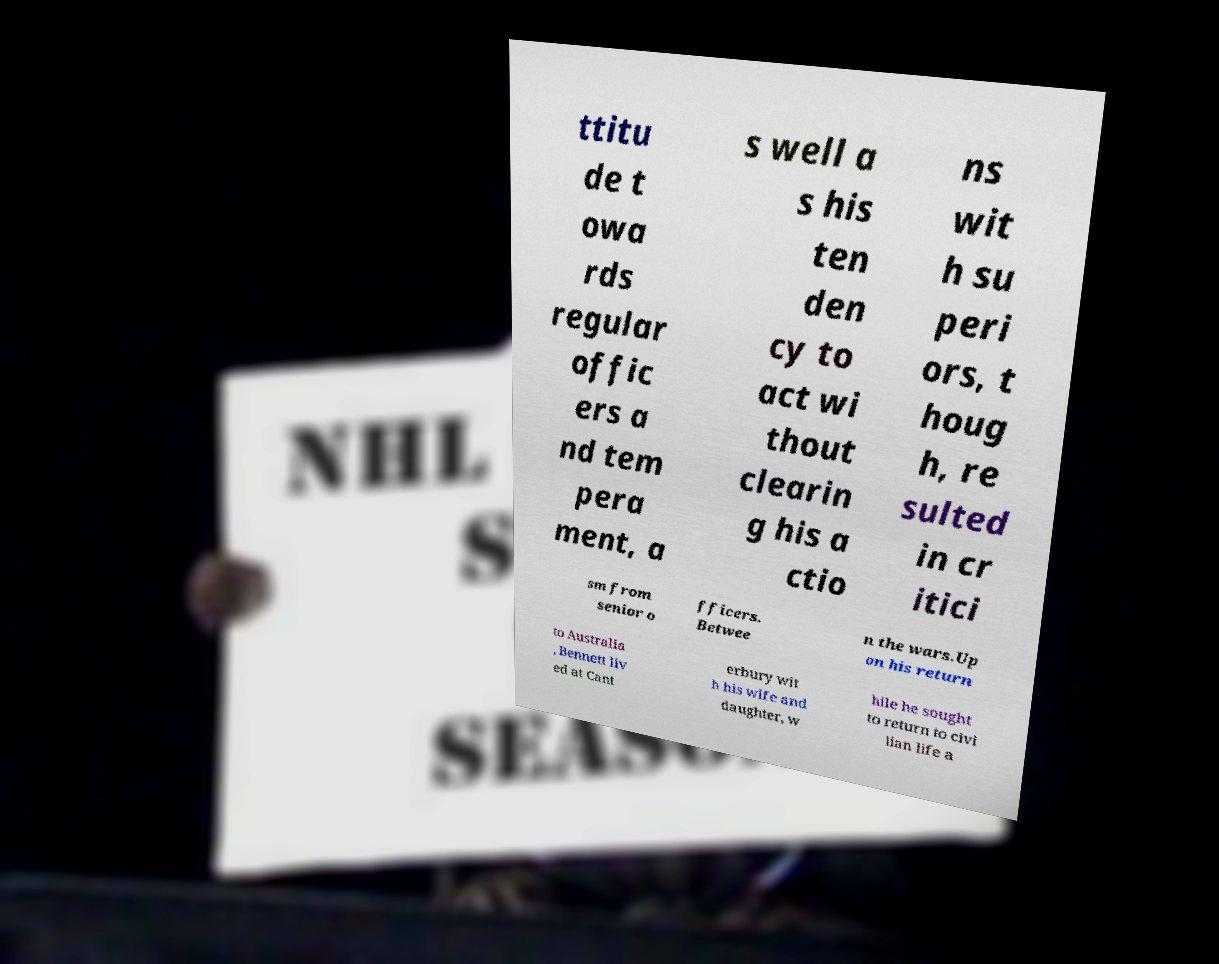Can you read and provide the text displayed in the image?This photo seems to have some interesting text. Can you extract and type it out for me? ttitu de t owa rds regular offic ers a nd tem pera ment, a s well a s his ten den cy to act wi thout clearin g his a ctio ns wit h su peri ors, t houg h, re sulted in cr itici sm from senior o fficers. Betwee n the wars.Up on his return to Australia , Bennett liv ed at Cant erbury wit h his wife and daughter, w hile he sought to return to civi lian life a 